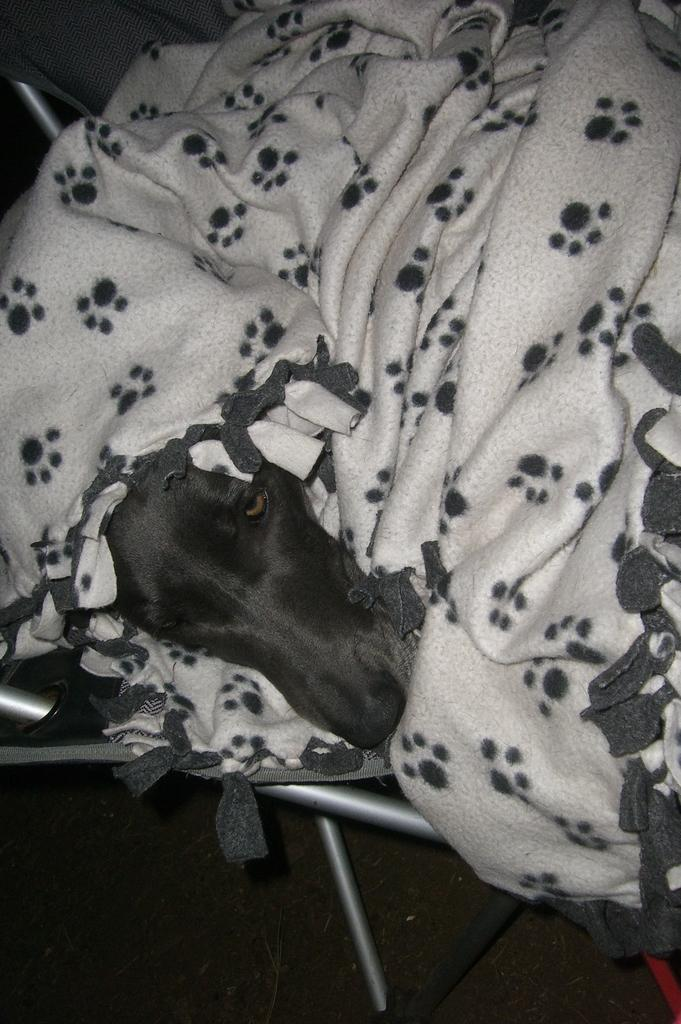What animal is present in the image? There is a dog in the image. How is the dog positioned in the image? The dog is inside a blanket. What is the color scheme of the image? The image is black and white. Where is the church located in the image? There is no church present in the image. How many friends are visible in the image? There are no friends visible in the image. 